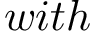Convert formula to latex. <formula><loc_0><loc_0><loc_500><loc_500>w i t h</formula> 